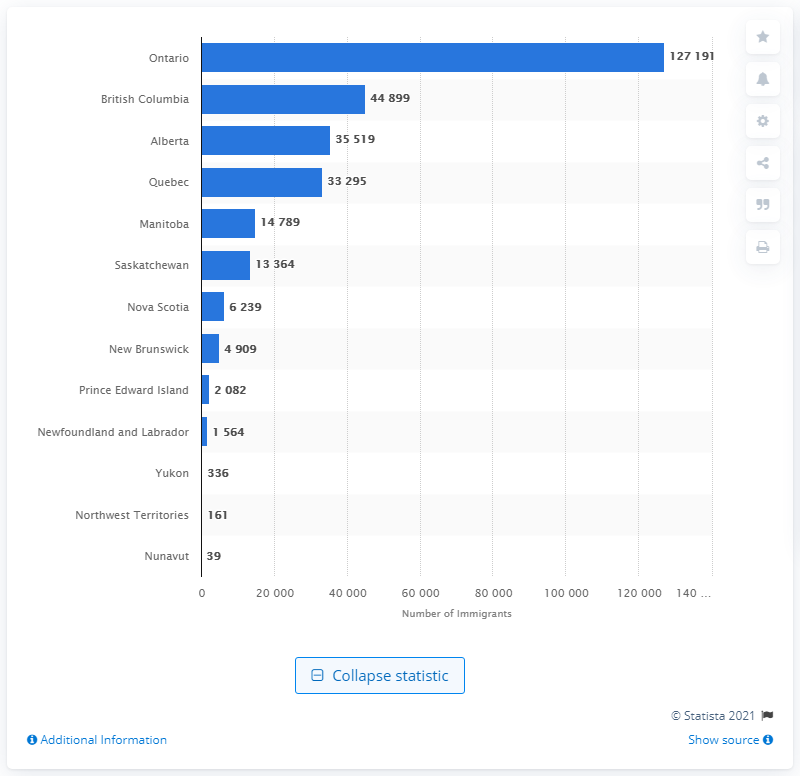Mention a couple of crucial points in this snapshot. In 2020, Ontario had the most immigrants among all the provinces. 